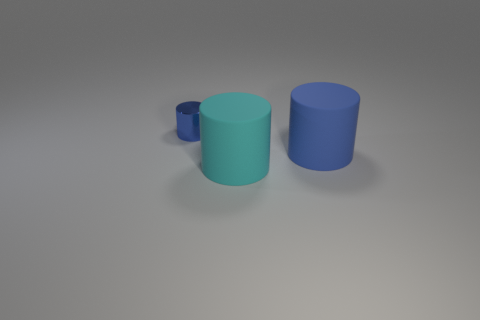The other cylinder that is made of the same material as the cyan cylinder is what size?
Provide a succinct answer. Large. What is the shape of the metallic thing?
Provide a succinct answer. Cylinder. Is the material of the tiny cylinder the same as the blue object to the right of the shiny object?
Offer a very short reply. No. How many things are tiny gray shiny spheres or small cylinders?
Your answer should be very brief. 1. Are any cylinders visible?
Your answer should be very brief. Yes. There is a object that is behind the blue cylinder that is in front of the tiny blue metal cylinder; what shape is it?
Your response must be concise. Cylinder. How many things are either cylinders to the left of the cyan matte object or blue cylinders that are to the left of the blue matte cylinder?
Your response must be concise. 1. There is a object that is the same size as the cyan rubber cylinder; what material is it?
Make the answer very short. Rubber. What is the color of the small metallic cylinder?
Give a very brief answer. Blue. What is the material of the thing that is both behind the large cyan matte cylinder and on the right side of the tiny metal cylinder?
Ensure brevity in your answer.  Rubber. 